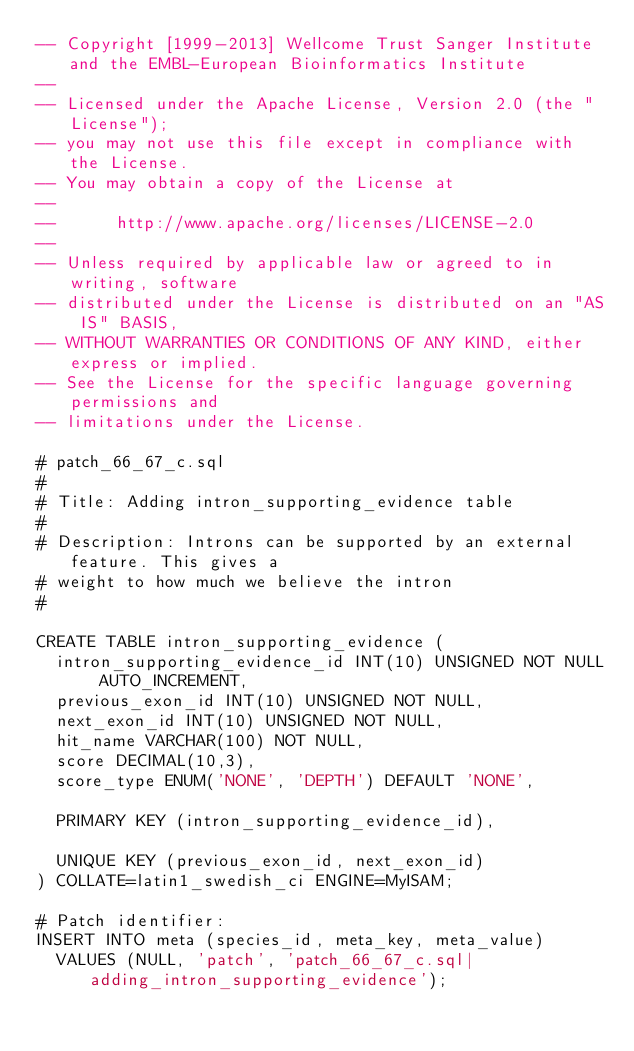<code> <loc_0><loc_0><loc_500><loc_500><_SQL_>-- Copyright [1999-2013] Wellcome Trust Sanger Institute and the EMBL-European Bioinformatics Institute
-- 
-- Licensed under the Apache License, Version 2.0 (the "License");
-- you may not use this file except in compliance with the License.
-- You may obtain a copy of the License at
-- 
--      http://www.apache.org/licenses/LICENSE-2.0
-- 
-- Unless required by applicable law or agreed to in writing, software
-- distributed under the License is distributed on an "AS IS" BASIS,
-- WITHOUT WARRANTIES OR CONDITIONS OF ANY KIND, either express or implied.
-- See the License for the specific language governing permissions and
-- limitations under the License.

# patch_66_67_c.sql
#
# Title: Adding intron_supporting_evidence table
#
# Description: Introns can be supported by an external feature. This gives a 
# weight to how much we believe the intron
# 

CREATE TABLE intron_supporting_evidence (
  intron_supporting_evidence_id INT(10) UNSIGNED NOT NULL AUTO_INCREMENT,
  previous_exon_id INT(10) UNSIGNED NOT NULL,
  next_exon_id INT(10) UNSIGNED NOT NULL,
  hit_name VARCHAR(100) NOT NULL,
  score DECIMAL(10,3),
  score_type ENUM('NONE', 'DEPTH') DEFAULT 'NONE',
  
  PRIMARY KEY (intron_supporting_evidence_id),
  
  UNIQUE KEY (previous_exon_id, next_exon_id)
) COLLATE=latin1_swedish_ci ENGINE=MyISAM;

# Patch identifier:
INSERT INTO meta (species_id, meta_key, meta_value)
  VALUES (NULL, 'patch', 'patch_66_67_c.sql|adding_intron_supporting_evidence');
</code> 